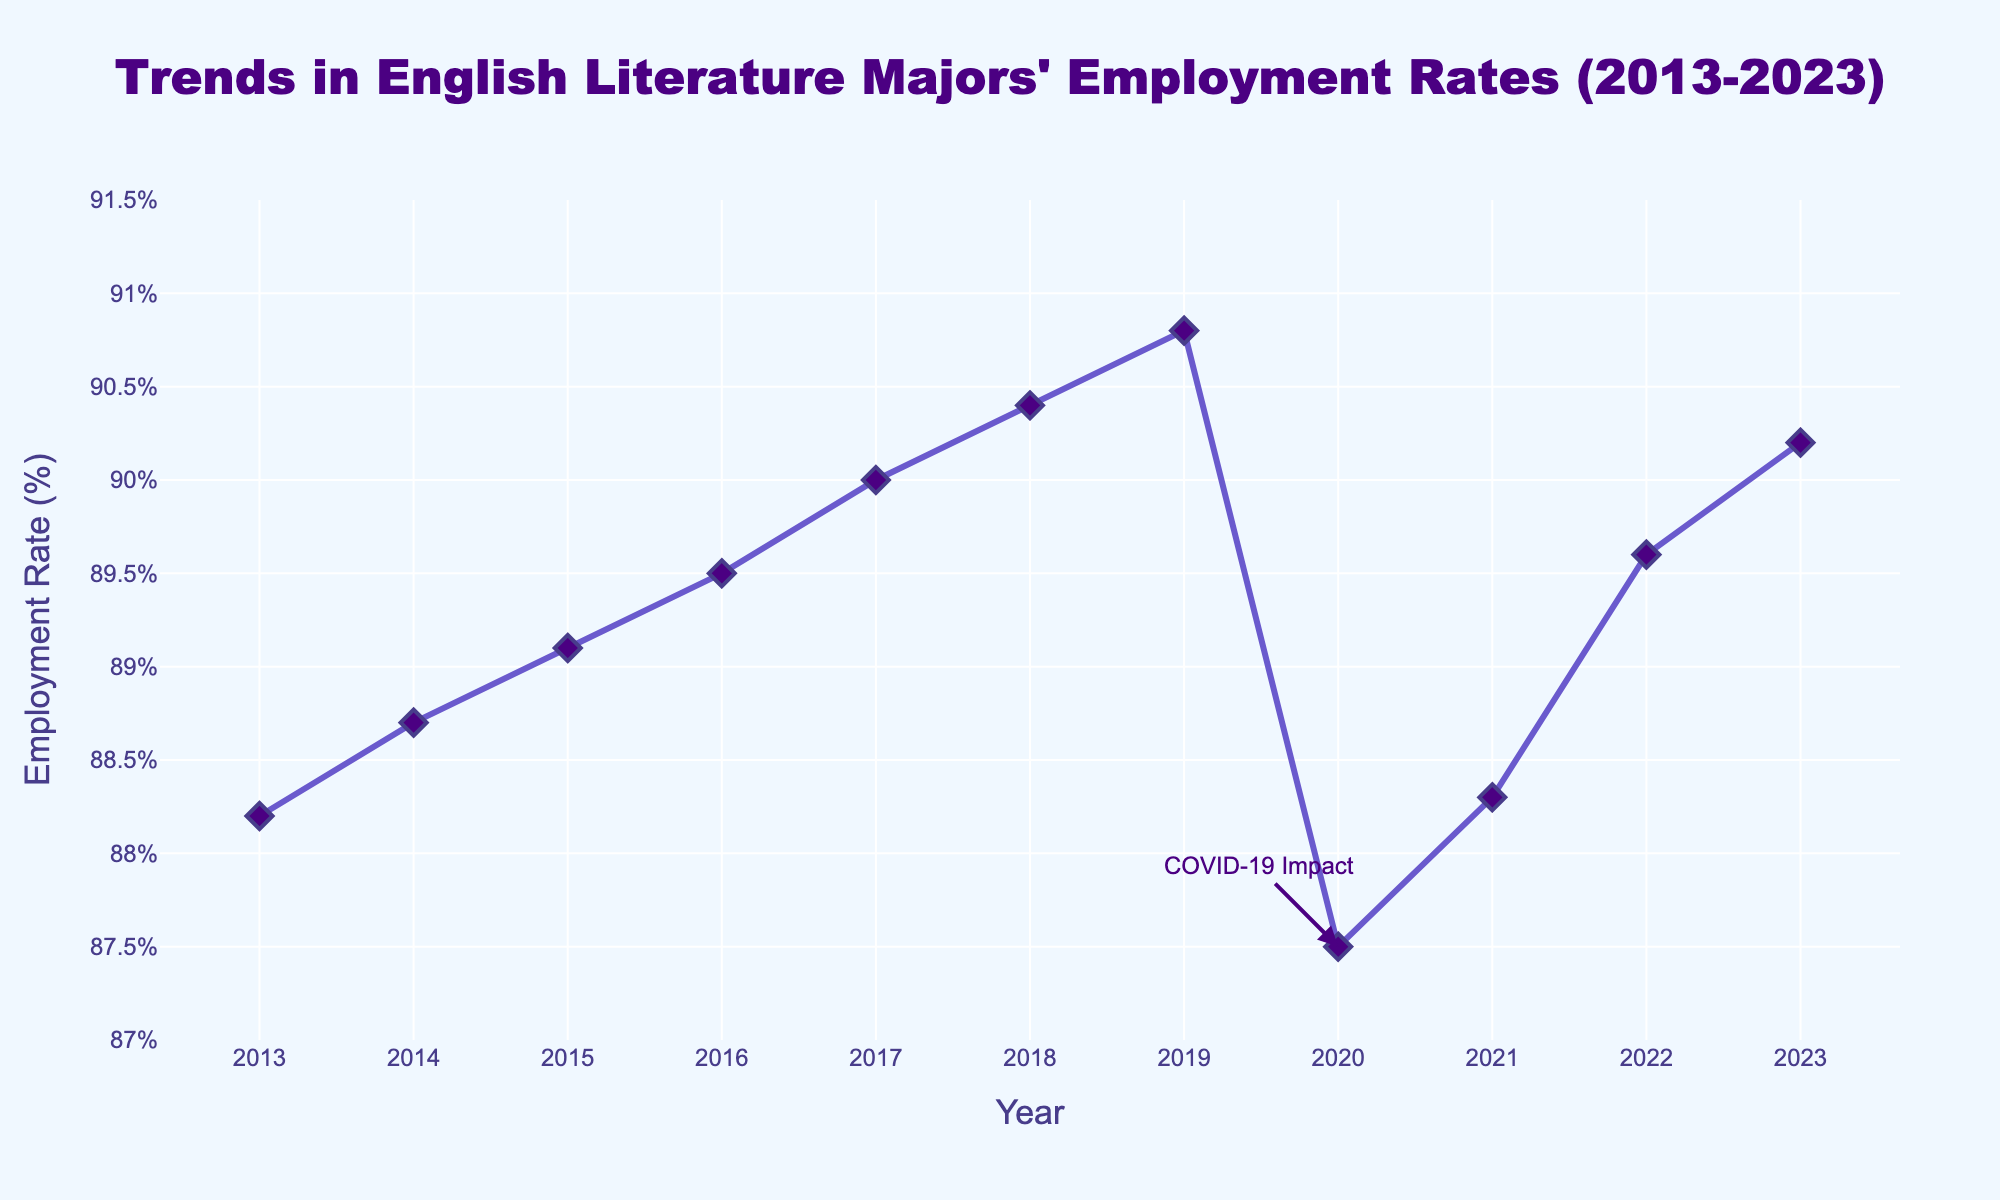What's the employment rate for English literature majors in 2023? To find the employment rate for 2023, look at the data point corresponding to the year 2023 on the x-axis. The value associated with it on the y-axis is 90.2%.
Answer: 90.2% How did the employment rate change from 2019 to 2020? To determine the change, note the employment rates for both years: 2019 (90.8%) and 2020 (87.5%). Subtract the 2020 value from the 2019 value: 90.8% - 87.5% = 3.3%.
Answer: Decreased by 3.3% Which year saw the lowest employment rate, and what was it? First identify the data point that is the lowest along the y-axis. This point is for the year 2020, with an employment rate of 87.5%.
Answer: 2020, 87.5% What was the employment rate's average over the decade from 2013 to 2023? Add all the employment rates from 2013 to 2023, then divide by the number of years (11). The sum is 88.2 + 88.7 + 89.1 + 89.5 + 90.0 + 90.4 + 90.8 + 87.5 + 88.3 + 89.6 + 90.2 = 981.3. Divide by 11: 981.3 / 11 ≈ 89.21%
Answer: 89.21% What is the trend in employment rates from 2016 to 2019? Observing the data points from 2016 to 2019: 89.5% (2016), 90.0% (2017), 90.4% (2018), 90.8% (2019). The employment rate increased each year over this period.
Answer: Increasing trend Which two consecutive years experienced the largest drop in employment rates? Examine the year-to-year differences and find the largest negative difference. The biggest drop is between 2019 (90.8%) and 2020 (87.5%) with a difference of 3.3%.
Answer: 2019 to 2020 How does the employment rate in 2023 compare to that in 2015? Check the values for 2023 (90.2%) and 2015 (89.1%). The employment rate in 2023 is higher than in 2015.
Answer: Higher in 2023 What is the median employment rate over the years shown? Arrange all the employment rates in order: 87.5, 88.2, 88.3, 88.7, 89.1, 89.5, 89.6, 90.0, 90.2, 90.4, 90.8. The middle value (6th value in an ordered list of 11) is 89.5%.
Answer: 89.5% What visual feature indicates a potential impact of COVID-19 on employment rates? The graph includes an annotation at the year 2020 noting "COVID-19 Impact," and this year also shows a noticeable drop in employment rates.
Answer: Annotation and drop in 2020 